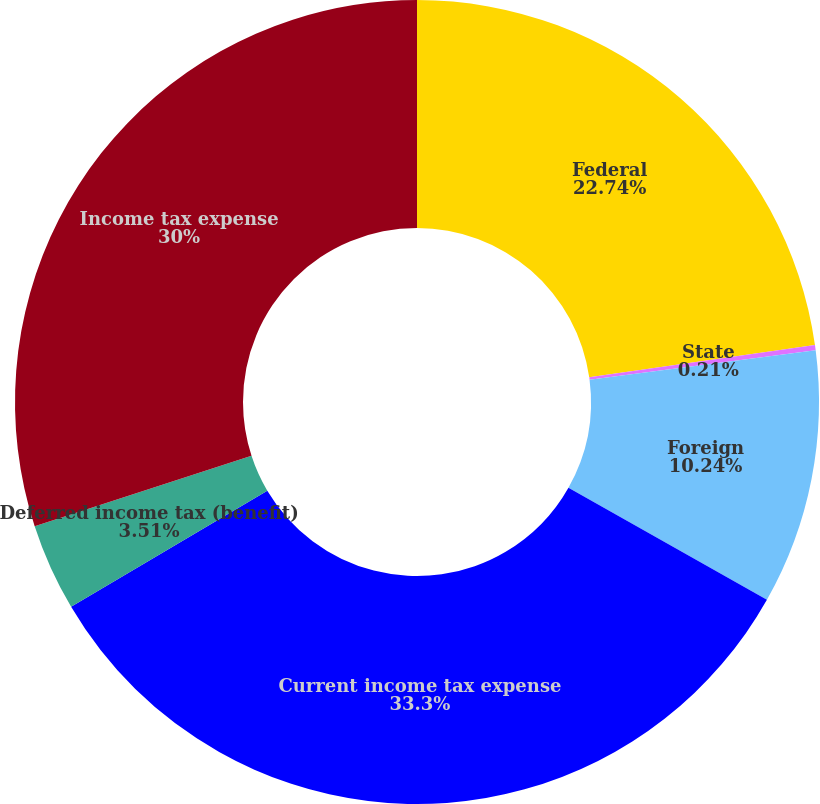<chart> <loc_0><loc_0><loc_500><loc_500><pie_chart><fcel>Federal<fcel>State<fcel>Foreign<fcel>Current income tax expense<fcel>Deferred income tax (benefit)<fcel>Income tax expense<nl><fcel>22.74%<fcel>0.21%<fcel>10.24%<fcel>33.3%<fcel>3.51%<fcel>30.0%<nl></chart> 